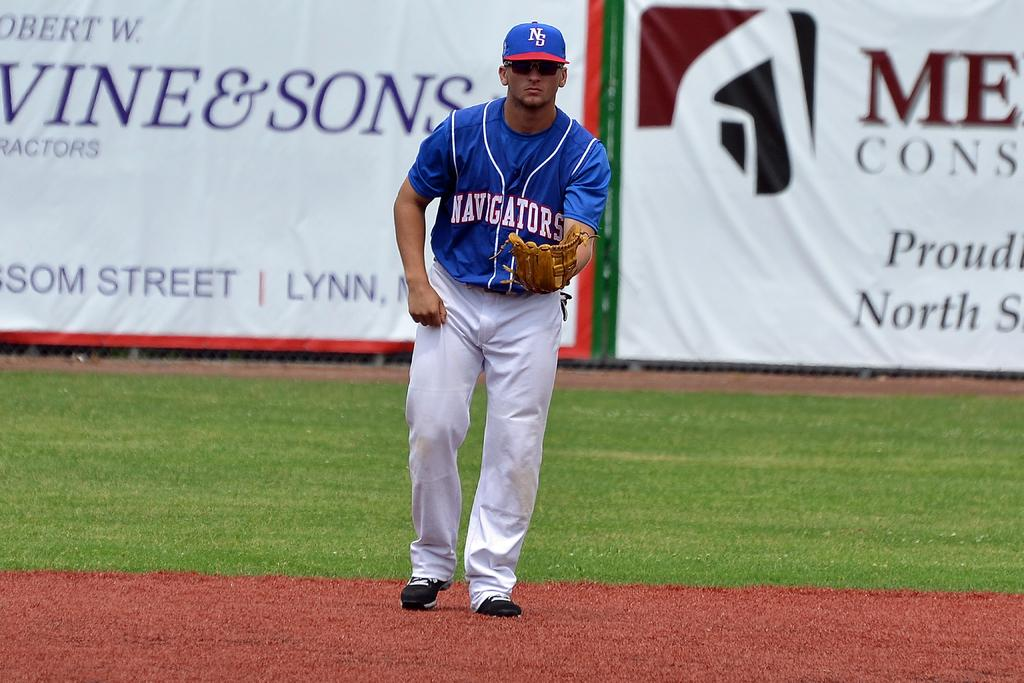<image>
Relay a brief, clear account of the picture shown. A baseball player that is on the Navigators team. 